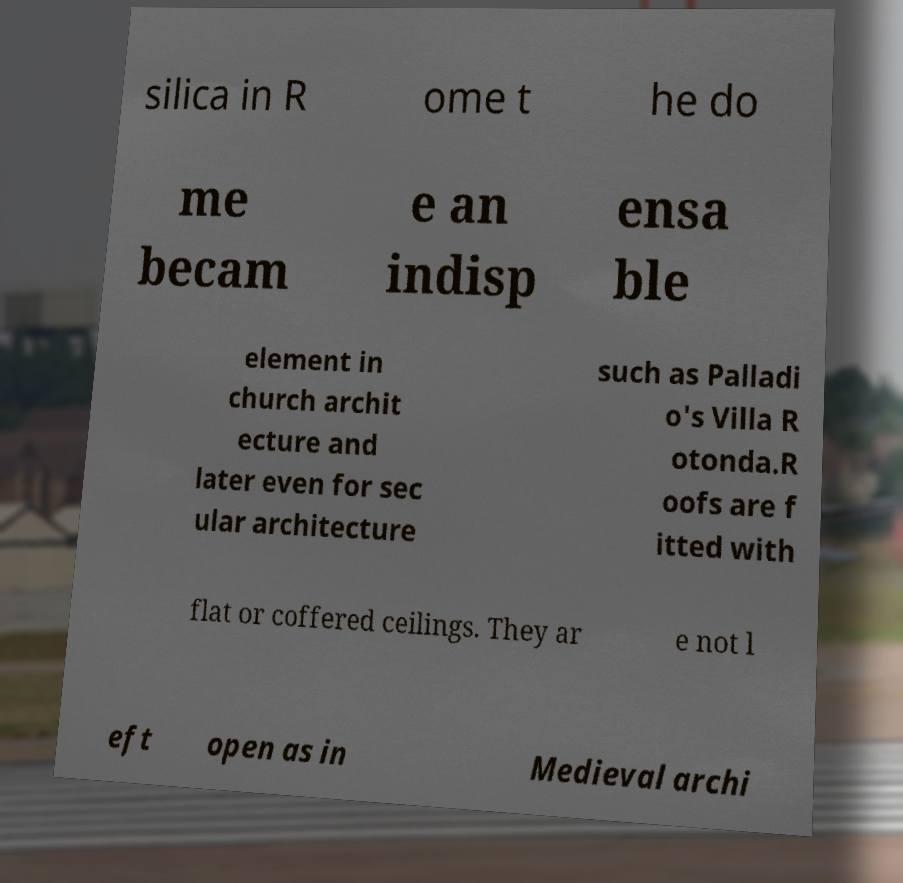Could you extract and type out the text from this image? silica in R ome t he do me becam e an indisp ensa ble element in church archit ecture and later even for sec ular architecture such as Palladi o's Villa R otonda.R oofs are f itted with flat or coffered ceilings. They ar e not l eft open as in Medieval archi 